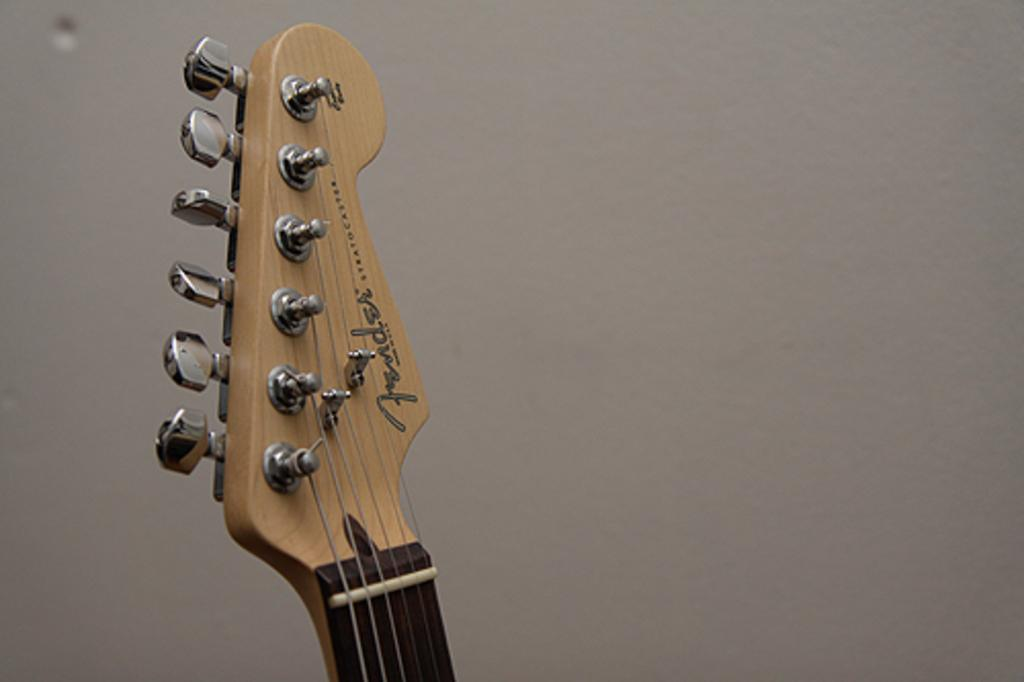What is the main subject of the image? The main subject of the image is a guitar head. What feature can be seen on the guitar head? The guitar head has tuners. How does the guitar head say good-bye to its partner before a performance? The guitar head does not have the ability to say good-bye or have a partner, as it is an inanimate object. 